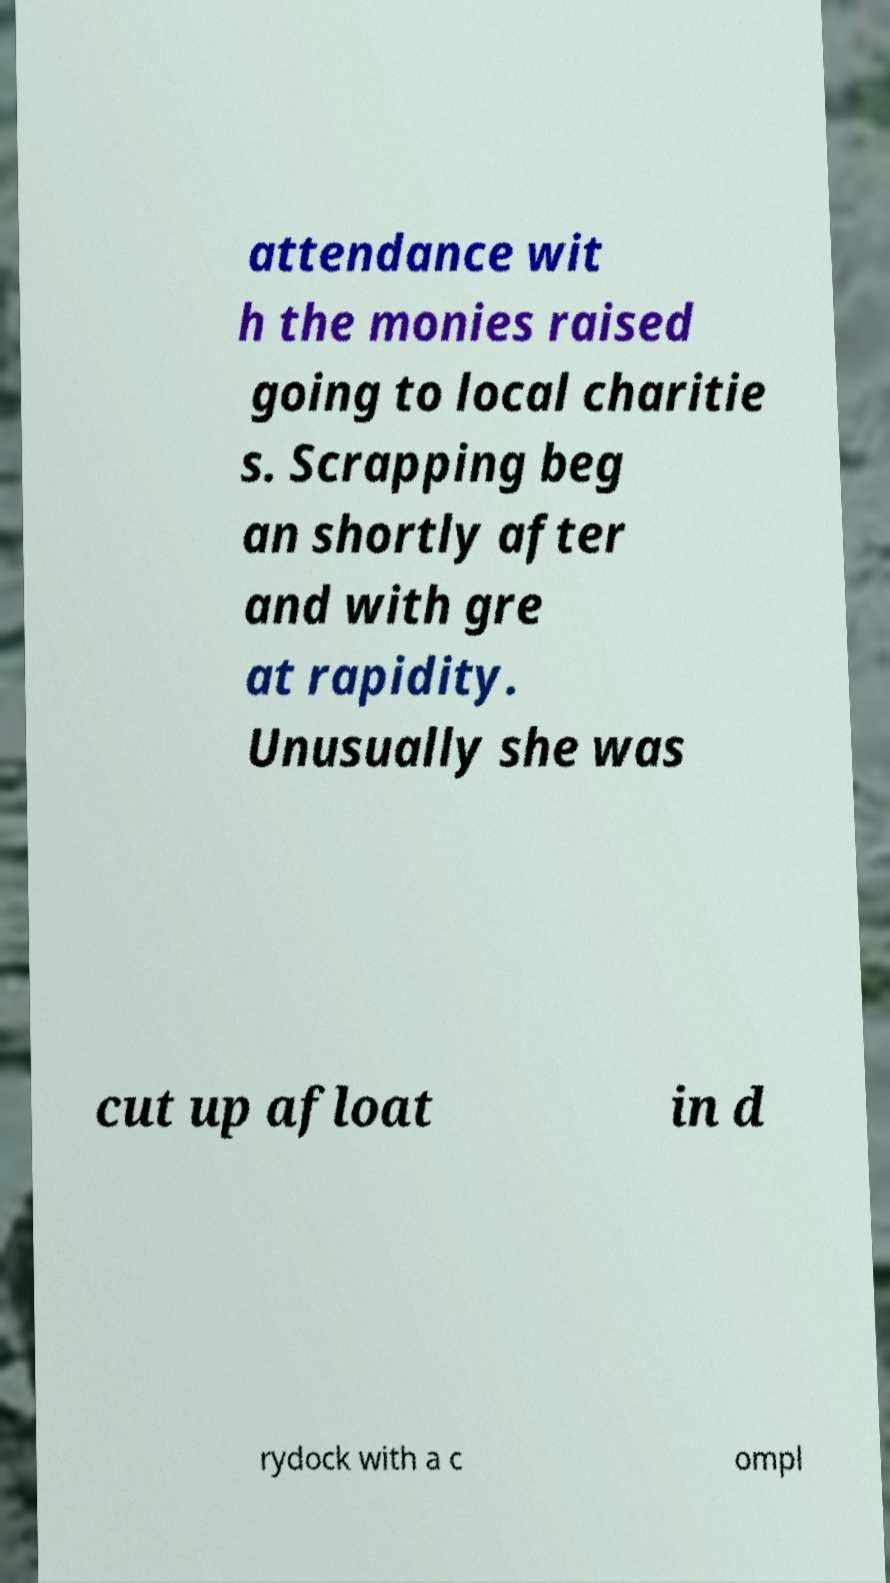For documentation purposes, I need the text within this image transcribed. Could you provide that? attendance wit h the monies raised going to local charitie s. Scrapping beg an shortly after and with gre at rapidity. Unusually she was cut up afloat in d rydock with a c ompl 